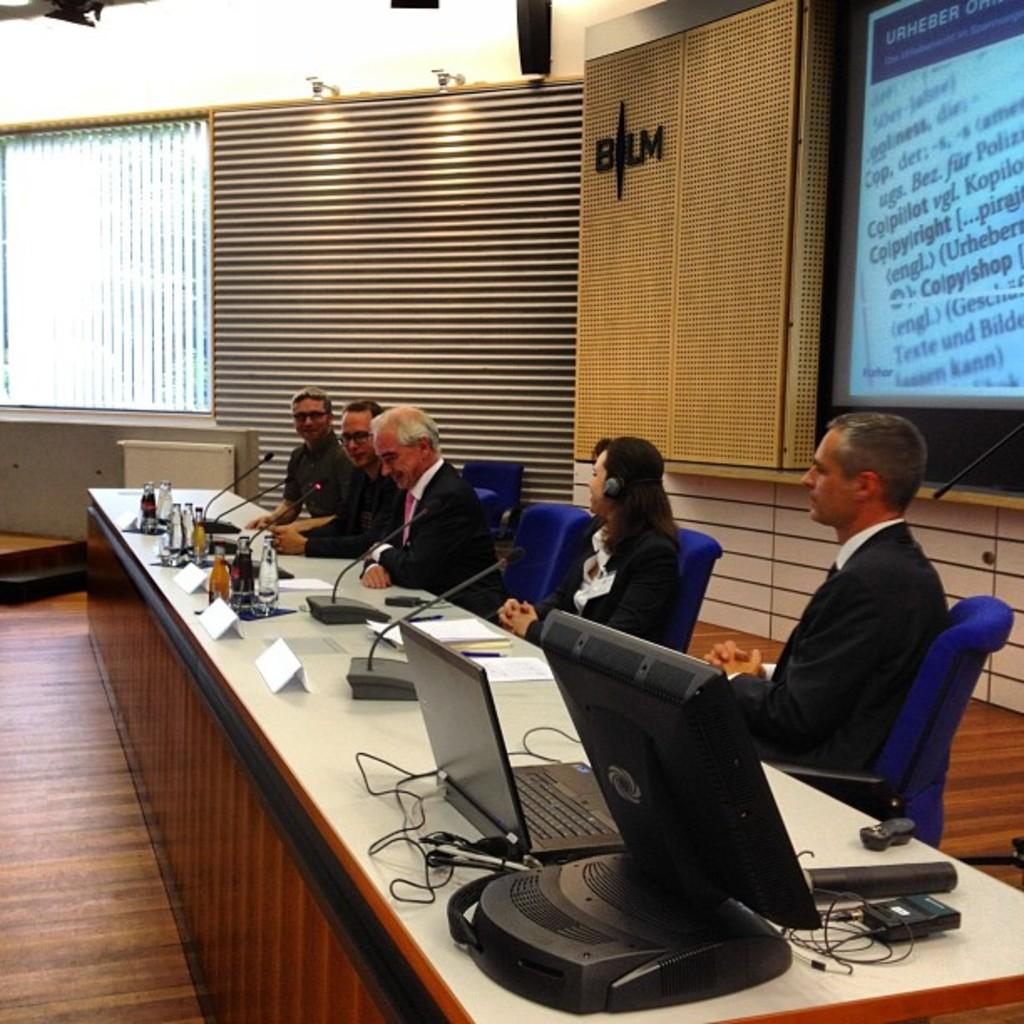Provide a one-sentence caption for the provided image. 5 people in suits are sitting at a panel in front of a BLM logo. 